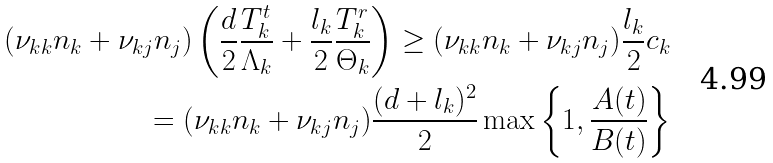<formula> <loc_0><loc_0><loc_500><loc_500>( \nu _ { k k } n _ { k } + \nu _ { k j } n _ { j } ) \left ( \frac { d } { 2 } \frac { T _ { k } ^ { t } } { \Lambda _ { k } } + \frac { l _ { k } } { 2 } \frac { T _ { k } ^ { r } } { \Theta _ { k } } \right ) \geq ( \nu _ { k k } n _ { k } + \nu _ { k j } n _ { j } ) \frac { l _ { k } } { 2 } c _ { k } \\ = ( \nu _ { k k } n _ { k } + \nu _ { k j } n _ { j } ) \frac { ( d + l _ { k } ) ^ { 2 } } { 2 } \max \left \{ 1 , \frac { A ( t ) } { B ( t ) } \right \}</formula> 